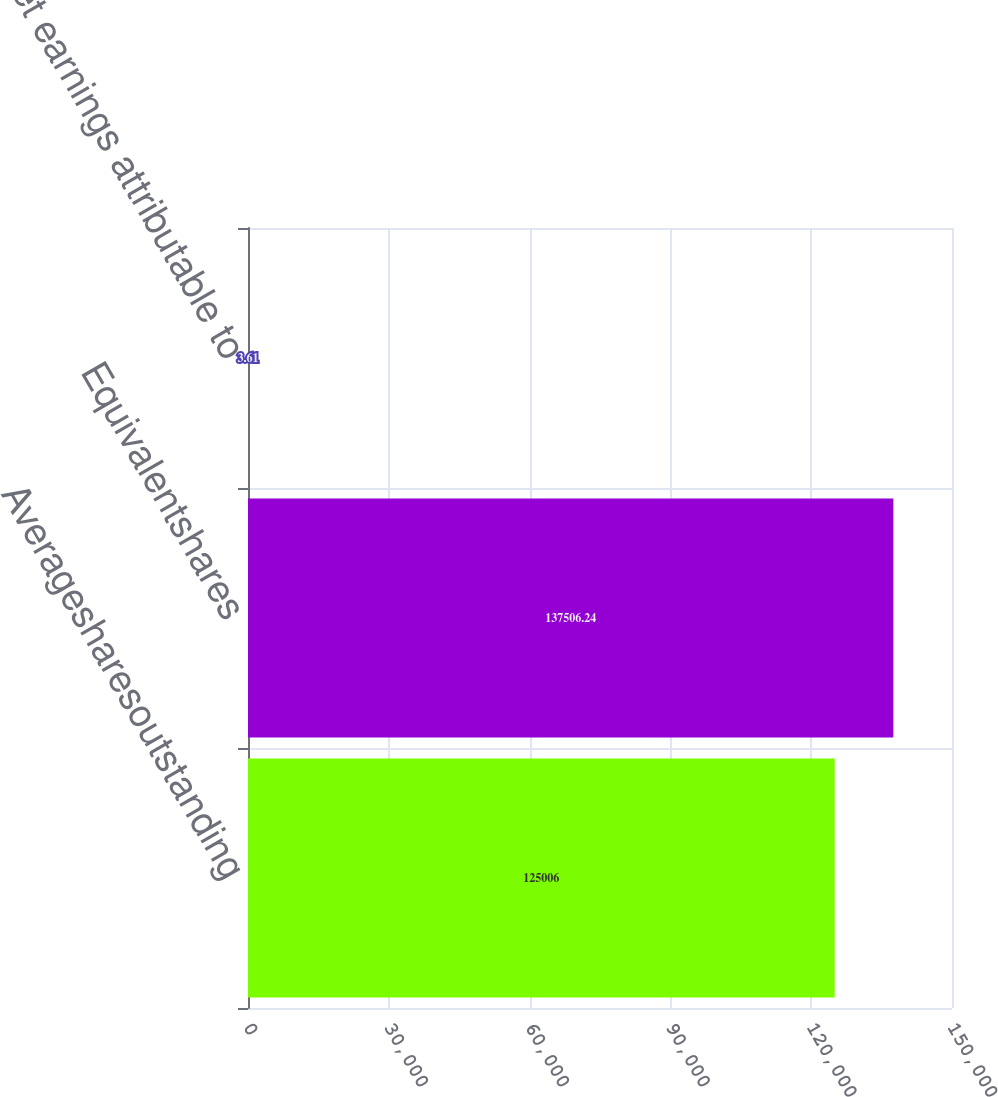Convert chart. <chart><loc_0><loc_0><loc_500><loc_500><bar_chart><fcel>Averagesharesoutstanding<fcel>Equivalentshares<fcel>Net earnings attributable to<nl><fcel>125006<fcel>137506<fcel>3.61<nl></chart> 